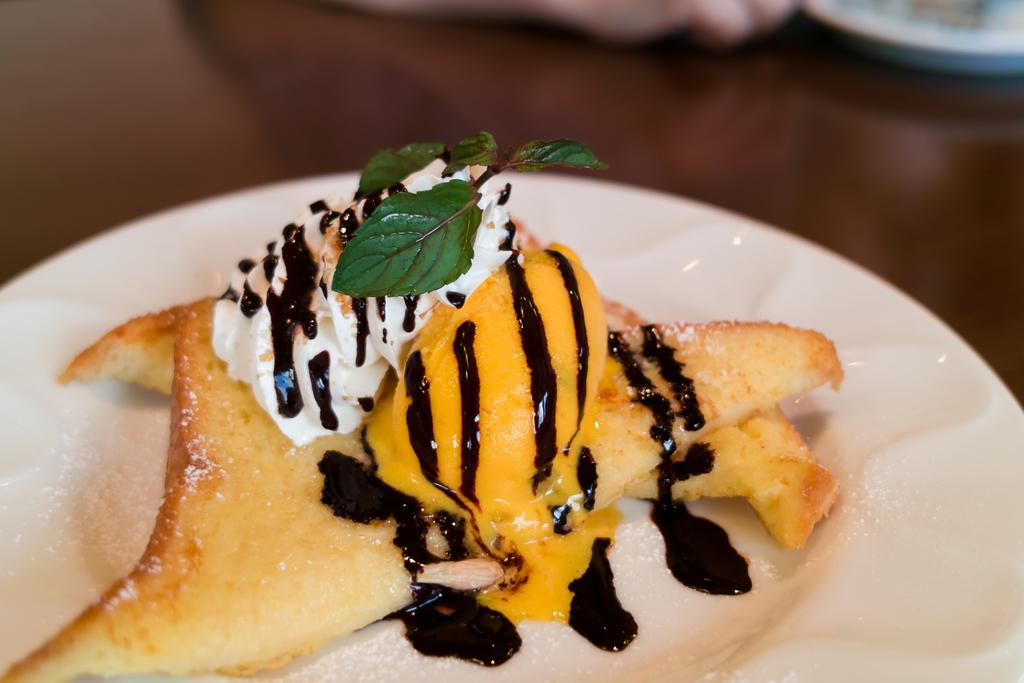What is on the plate that is visible in the image? There is a plate of food item in the image. What is the plate placed on? The plate is placed on a wooden table. Whose hand is visible in the image? A person's hand is visible in the image. Can you describe the object at the top of the image? There is not present in the image. What type of furniture is the manager sitting on in the image? There is no manager or furniture present in the image. 